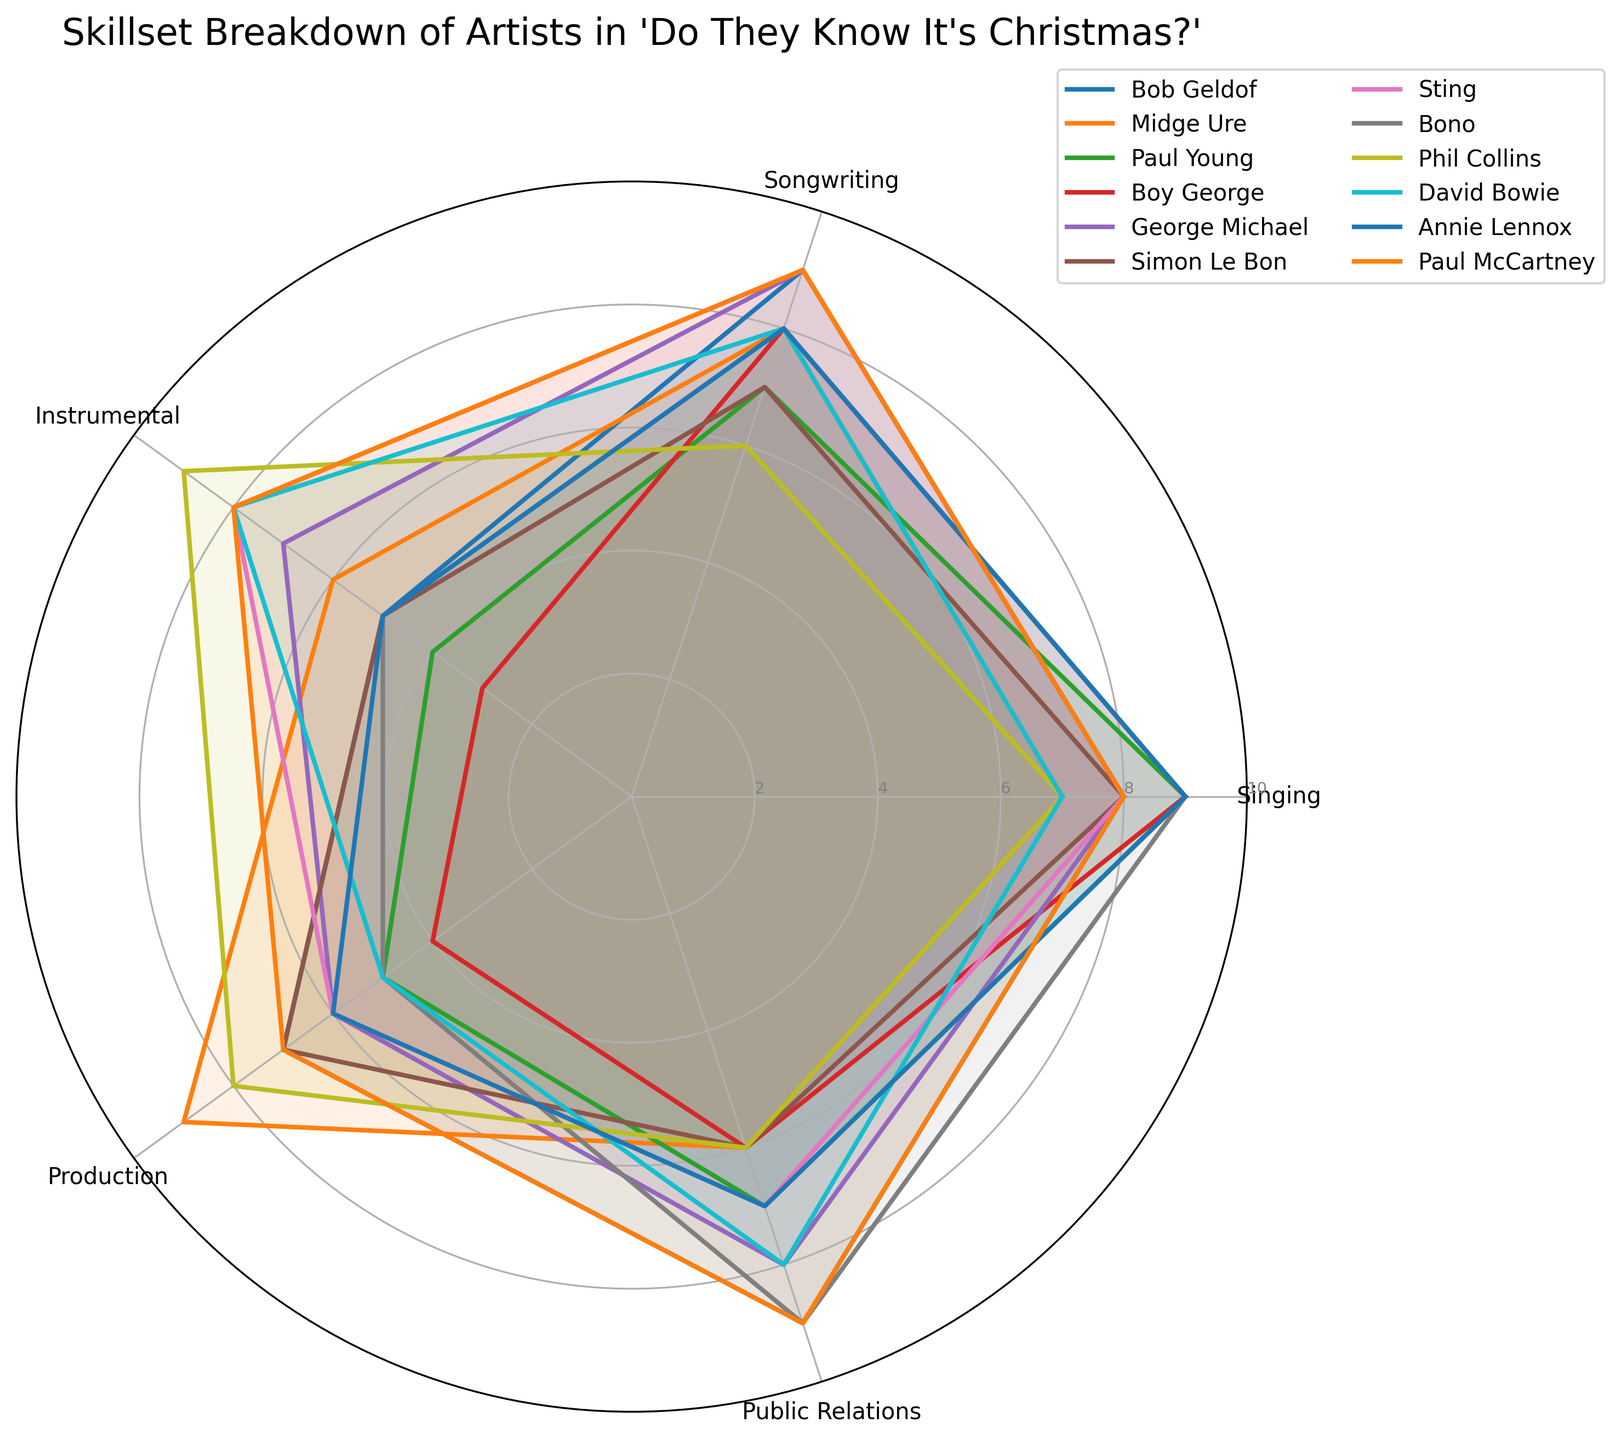what is the highest score in the Singing category and who achieved it? The highest score in the Singing category can be found by inspecting all the plotted lines in the radar chart and identifying the maximum value. Paul Young, Boy George, Bono, and Annie Lennox all have the highest score of 9 in Singing.
Answer: Paul Young, Boy George, Bono, Annie Lennox which artist has the most balanced skillset, i.e., whose scores are closest to each other across all categories? A balanced skillset means that an artist's scores across all categories are similar. We would look for a radar plot that appears more circular and evenly distributed. Sting has fairly balanced scores (7s, 8s, 9s) across categories.
Answer: Sting how many artists have a Production score of 9? To find this, look at the Production axis and count how many lines reach the score of 9. Bob Geldof, Midge Ure, and Paul McCartney all have a Production score of 9.
Answer: 3 which artist has the highest combined score across all categories? To find this, each artist's scores across all categories need to be summed up. The artist with the highest total is Paul McCartney with a combined score of 41.
Answer: Paul McCartney who scores highest in Public Relations and how does their Singing skill compare? The highest score in Public Relations needs to be identified first, which is achieved by Bob Geldof and Bono with a score of 9. Then, compare their Singing scores: Bob Geldof scores 8 and Bono scores 9 in Singing.
Answer: Bono has higher Singing skill, 9 whose instrumental score is the highest? Find the maximum score on the Instrumental category axis. Phil Collins, Sting, and Paul McCartney have the highest Instrumental score of 8.
Answer: Phil Collins, Sting, Paul McCartney which artist has the most significant difference between their highest and lowest category scores? Calculate the difference between the highest and lowest scores for each artist and identify the greatest difference. Boy George has the highest difference of 9 - 3 = 6.
Answer: Boy George which two artists share the same scores in the Songwriting category? Find artists with identical values on the Songwriting axis. Bob Geldof, and George Michael both have a Songwriting score of 9.
Answer: Bob Geldof, George Michael does any artist score consistently higher than 5 in all categories? Verify for each artist if all their scores across the categories are higher than 5. Paul McCartney, Bob Geldof, George Michael, Sting, and Bono score higher than 5 in all categories.
Answer: Paul McCartney, Bob Geldof, George Michael, Sting, Bono 